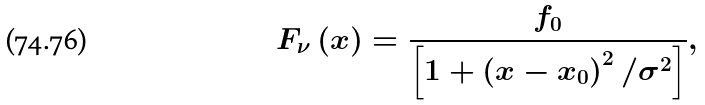Convert formula to latex. <formula><loc_0><loc_0><loc_500><loc_500>F _ { \nu } \left ( x \right ) = \frac { f _ { 0 } } { \left [ 1 + \left ( x - x _ { 0 } \right ) ^ { 2 } / \sigma ^ { 2 } \right ] } ,</formula> 